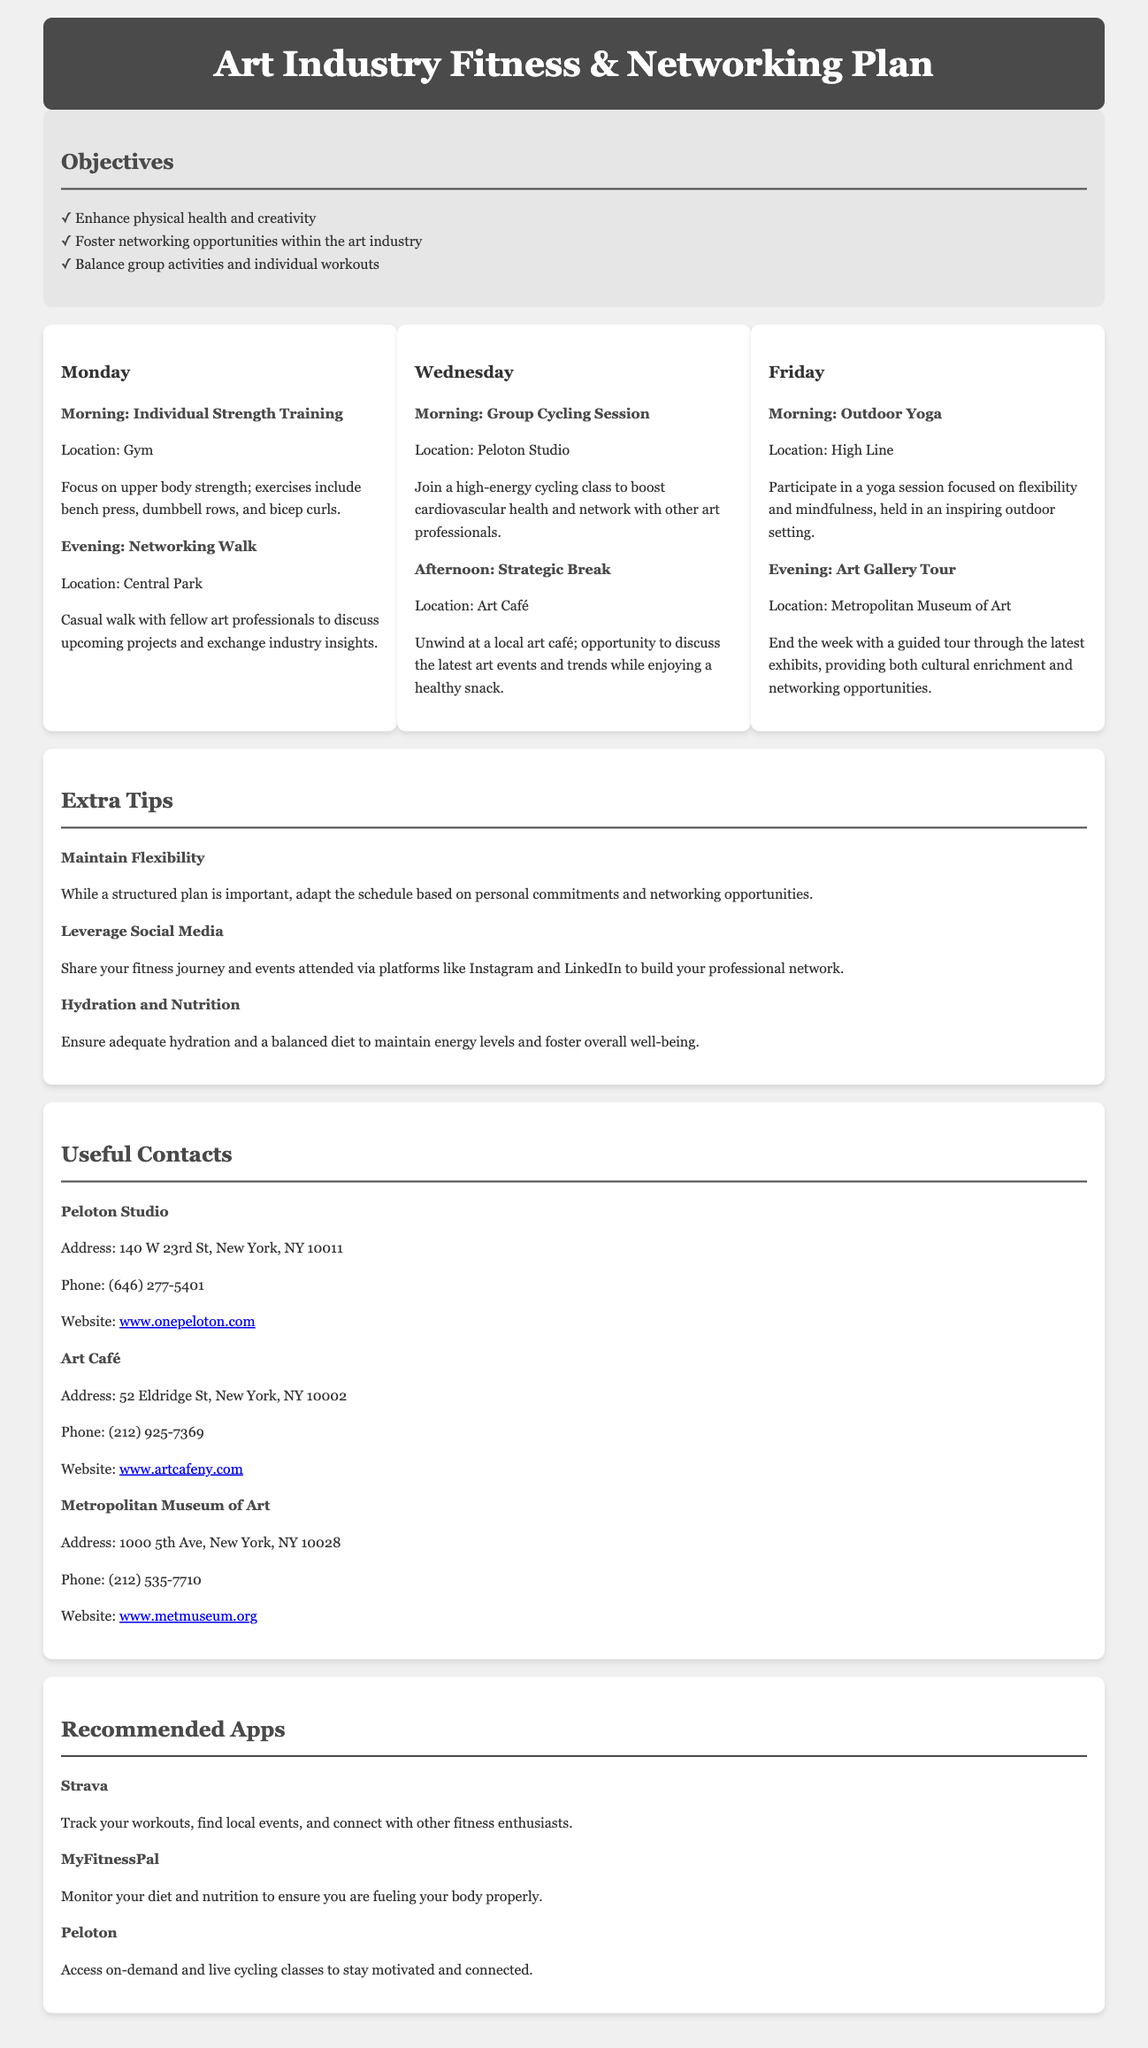What are the main objectives of the plan? The objectives include enhancing physical health and creativity, fostering networking opportunities, and balancing group activities with individual workouts.
Answer: Enhance physical health and creativity, foster networking opportunities within the art industry, balance group activities and individual workouts How many days are scheduled for activities in this plan? The plan outlines activities for three days: Monday, Wednesday, and Friday.
Answer: 3 What activity is scheduled for Monday evening? The document states that a networking walk is scheduled for Monday evening at Central Park.
Answer: Networking Walk What is the location for the Wednesday afternoon strategic break? The strategic break is set to take place at Art Café.
Answer: Art Café What type of activity is planned for Friday morning? The plan indicates that an outdoor yoga session is scheduled for Friday morning.
Answer: Outdoor Yoga Which app is recommended for tracking workouts? The recommended app for tracking workouts mentioned in the document is Strava.
Answer: Strava What type of session is included on Wednesday morning? The plan includes a group cycling session on Wednesday morning.
Answer: Group Cycling Session What is the focus of the individual strength training on Monday morning? The focus for Monday morning's individual strength training is on upper body strength.
Answer: Upper body strength 